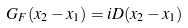<formula> <loc_0><loc_0><loc_500><loc_500>G _ { F } ( x _ { 2 } - x _ { 1 } ) = i D ( x _ { 2 } - x _ { 1 } )</formula> 